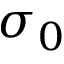Convert formula to latex. <formula><loc_0><loc_0><loc_500><loc_500>\sigma _ { 0 }</formula> 